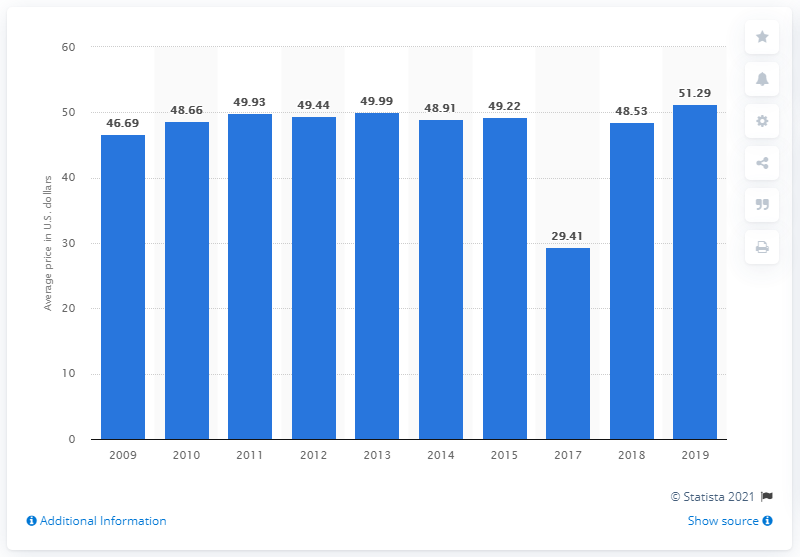Indicate a few pertinent items in this graphic. The average price for a full set of gel nails in the United States from 2009 to 2019 was approximately $51.29. 